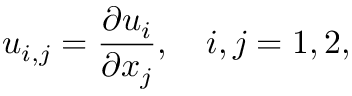Convert formula to latex. <formula><loc_0><loc_0><loc_500><loc_500>u _ { i , j } = \frac { \partial u _ { i } } { \partial x _ { j } } , \quad i , j = 1 , 2 ,</formula> 